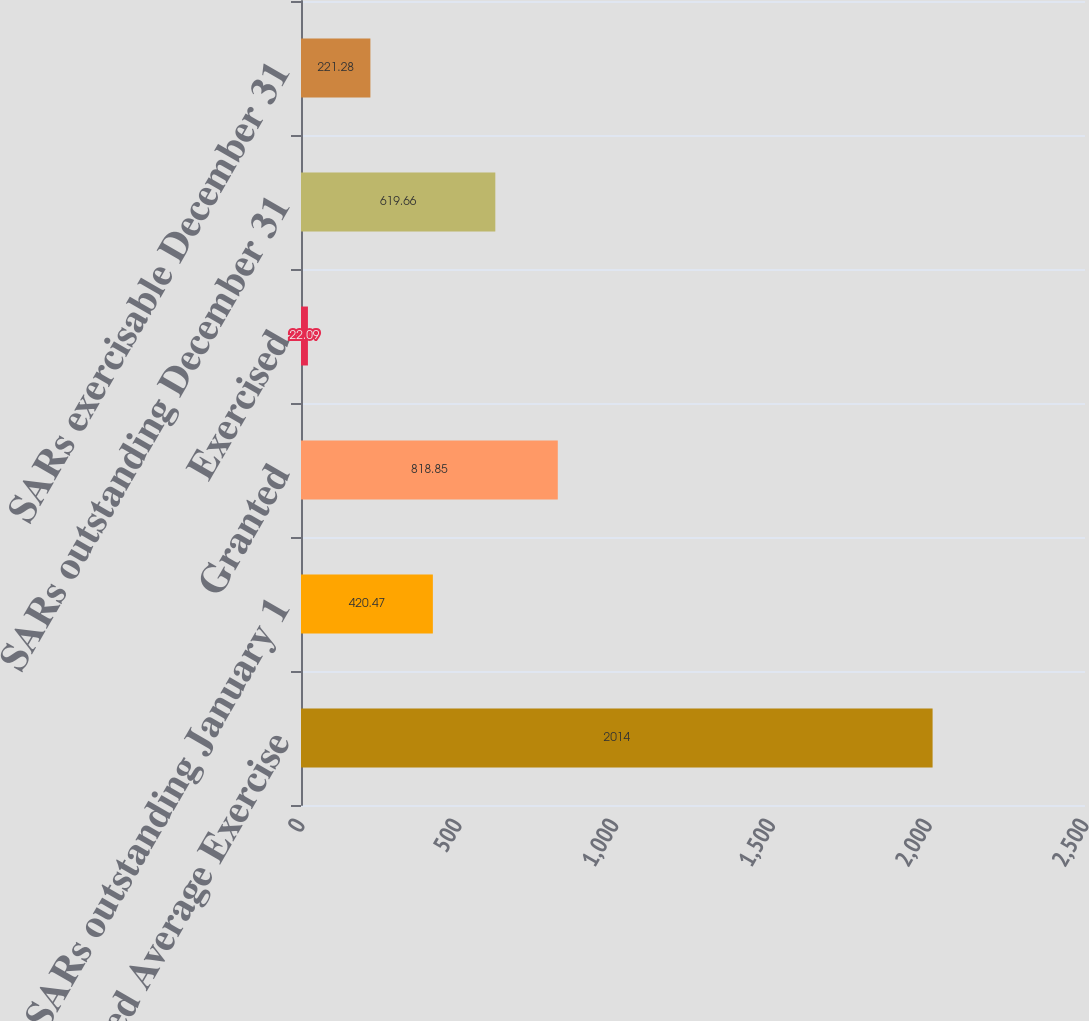<chart> <loc_0><loc_0><loc_500><loc_500><bar_chart><fcel>Weighted Average Exercise<fcel>SARs outstanding January 1<fcel>Granted<fcel>Exercised<fcel>SARs outstanding December 31<fcel>SARs exercisable December 31<nl><fcel>2014<fcel>420.47<fcel>818.85<fcel>22.09<fcel>619.66<fcel>221.28<nl></chart> 